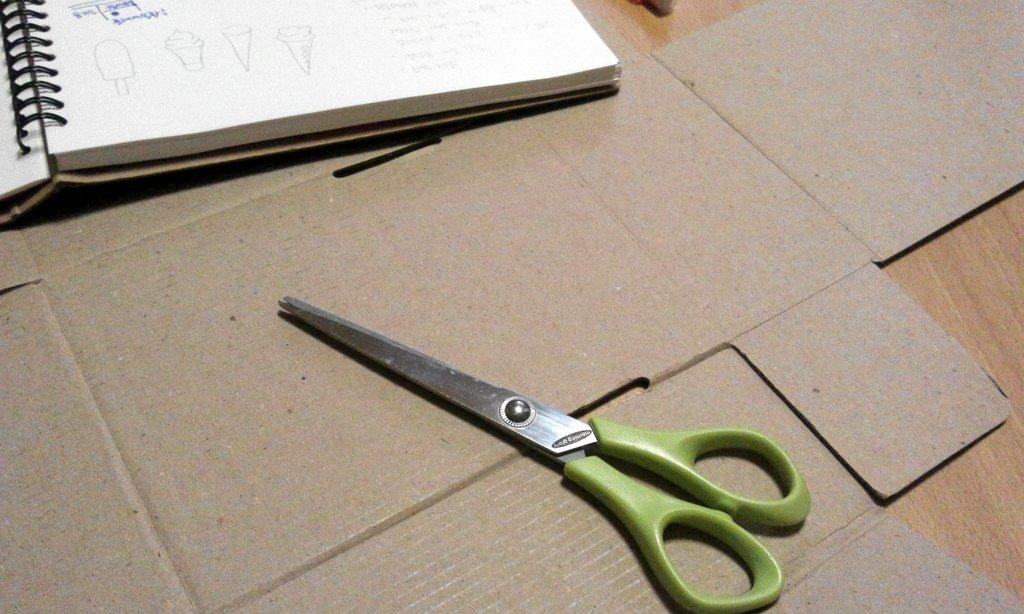What object can be seen in the image related to reading or learning? There is a book in the image related to reading or learning. What object can be seen in the image that is typically used for cutting or trimming? There is a scissor in the image that is typically used for cutting or trimming. On what surface are the book and scissor placed in the image? Both the book and scissor are placed on a cardboard in the image. What rhythm does the grandfather in the image tap while reading the book? There is no grandfather present in the image, and therefore no rhythm can be observed. 